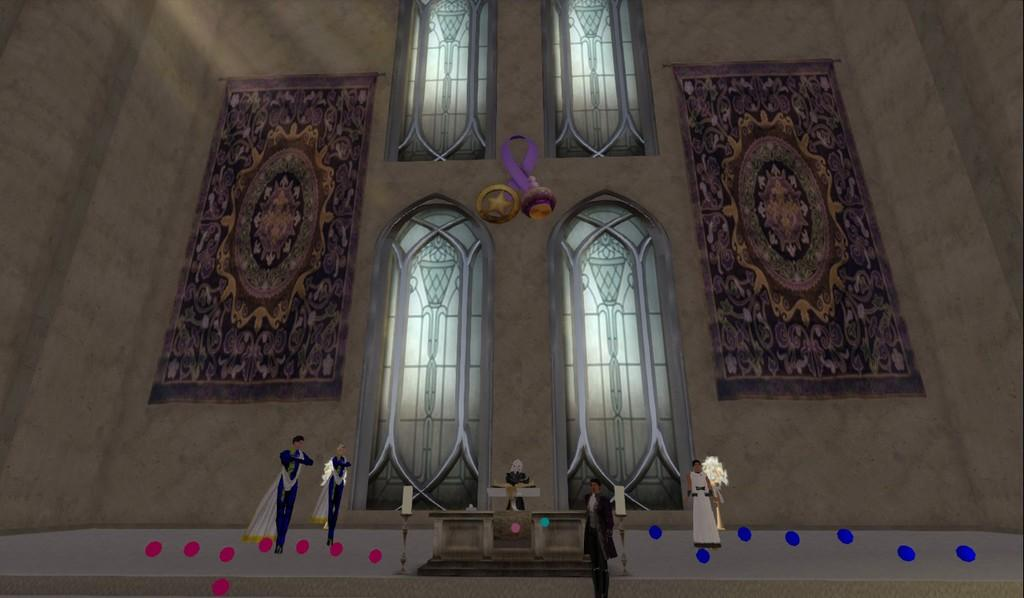How many person statues are in the foreground of the image? There are five person statues in the foreground of the image. What can be seen in the background of the image? There are windows, stone craft, and a wall in the background of the image. What type of structure might the image have been taken in? The image may have been taken in a church, based on the presence of person statues and the possible architectural features. How many tickets are required to enter the image? There are no tickets present in the image, as it is a photograph and not an event or location that requires admission. 